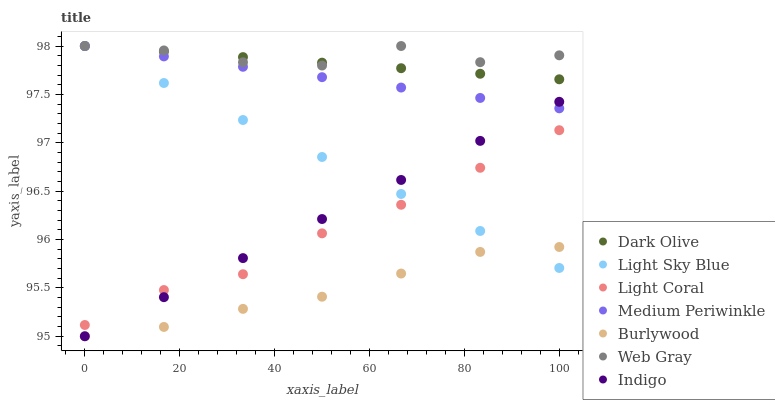Does Burlywood have the minimum area under the curve?
Answer yes or no. Yes. Does Web Gray have the maximum area under the curve?
Answer yes or no. Yes. Does Indigo have the minimum area under the curve?
Answer yes or no. No. Does Indigo have the maximum area under the curve?
Answer yes or no. No. Is Medium Periwinkle the smoothest?
Answer yes or no. Yes. Is Web Gray the roughest?
Answer yes or no. Yes. Is Indigo the smoothest?
Answer yes or no. No. Is Indigo the roughest?
Answer yes or no. No. Does Indigo have the lowest value?
Answer yes or no. Yes. Does Dark Olive have the lowest value?
Answer yes or no. No. Does Light Sky Blue have the highest value?
Answer yes or no. Yes. Does Indigo have the highest value?
Answer yes or no. No. Is Burlywood less than Light Coral?
Answer yes or no. Yes. Is Web Gray greater than Indigo?
Answer yes or no. Yes. Does Light Sky Blue intersect Indigo?
Answer yes or no. Yes. Is Light Sky Blue less than Indigo?
Answer yes or no. No. Is Light Sky Blue greater than Indigo?
Answer yes or no. No. Does Burlywood intersect Light Coral?
Answer yes or no. No. 